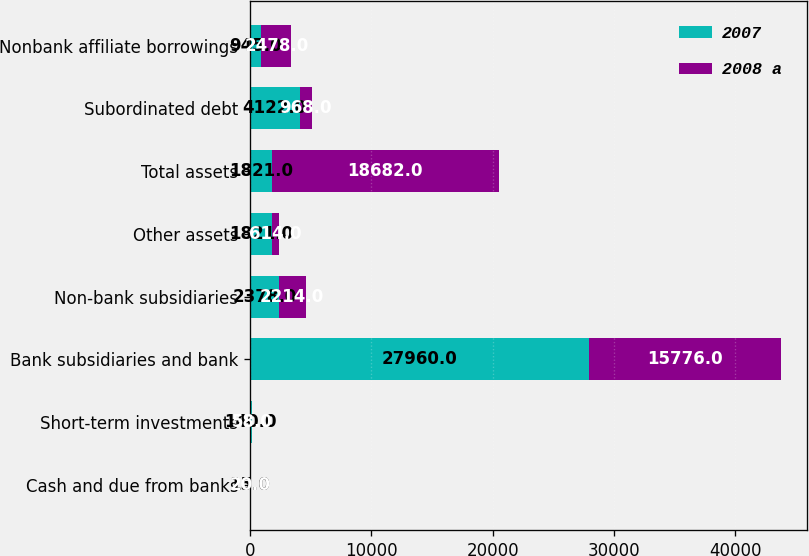<chart> <loc_0><loc_0><loc_500><loc_500><stacked_bar_chart><ecel><fcel>Cash and due from banks<fcel>Short-term investments<fcel>Bank subsidiaries and bank<fcel>Non-bank subsidiaries<fcel>Other assets<fcel>Total assets<fcel>Subordinated debt<fcel>Nonbank affiliate borrowings<nl><fcel>2007<fcel>15<fcel>140<fcel>27960<fcel>2378<fcel>1821<fcel>1821<fcel>4122<fcel>945<nl><fcel>2008 a<fcel>20<fcel>58<fcel>15776<fcel>2214<fcel>614<fcel>18682<fcel>968<fcel>2478<nl></chart> 